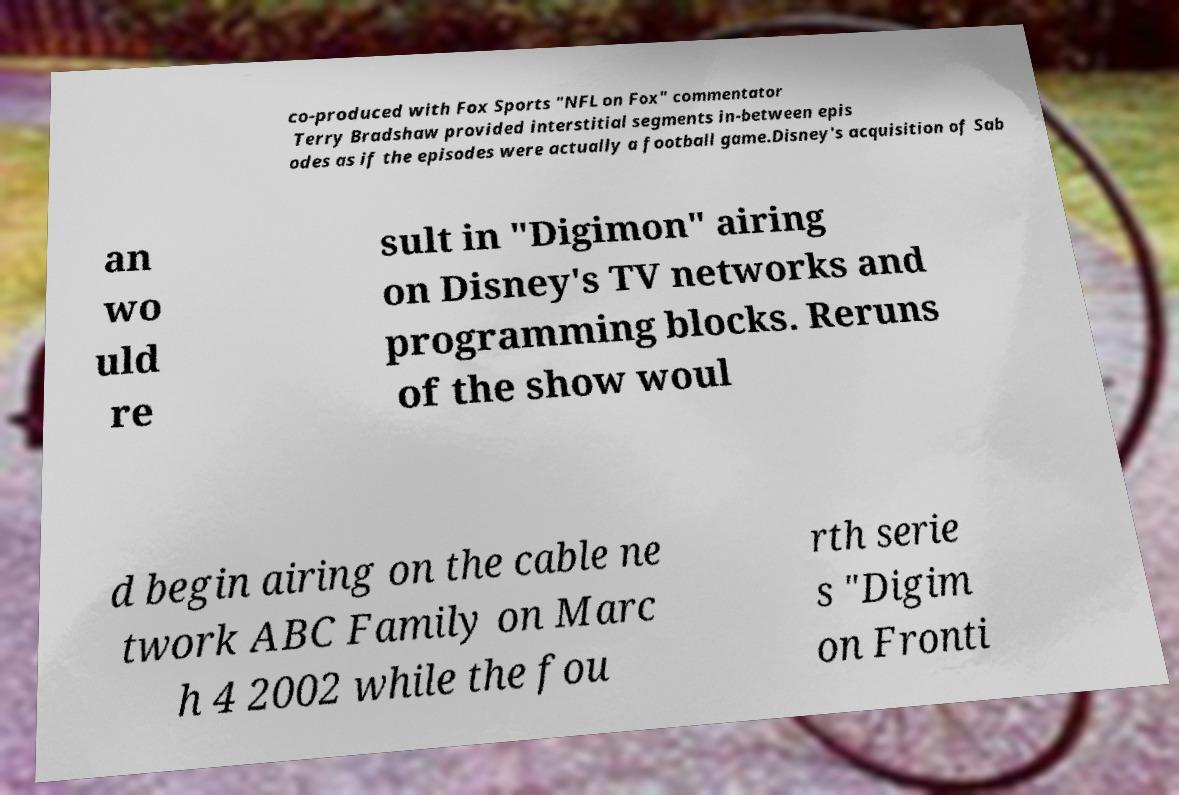Please read and relay the text visible in this image. What does it say? co-produced with Fox Sports "NFL on Fox" commentator Terry Bradshaw provided interstitial segments in-between epis odes as if the episodes were actually a football game.Disney's acquisition of Sab an wo uld re sult in "Digimon" airing on Disney's TV networks and programming blocks. Reruns of the show woul d begin airing on the cable ne twork ABC Family on Marc h 4 2002 while the fou rth serie s "Digim on Fronti 